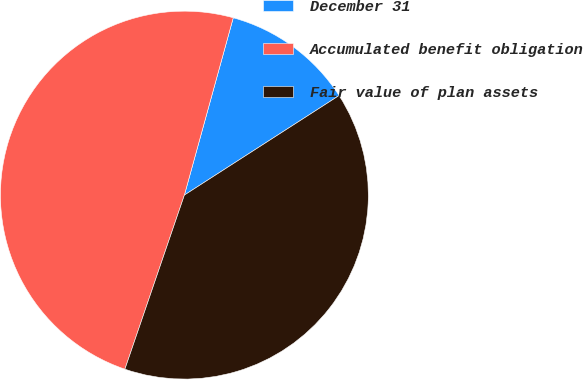<chart> <loc_0><loc_0><loc_500><loc_500><pie_chart><fcel>December 31<fcel>Accumulated benefit obligation<fcel>Fair value of plan assets<nl><fcel>11.62%<fcel>49.04%<fcel>39.34%<nl></chart> 